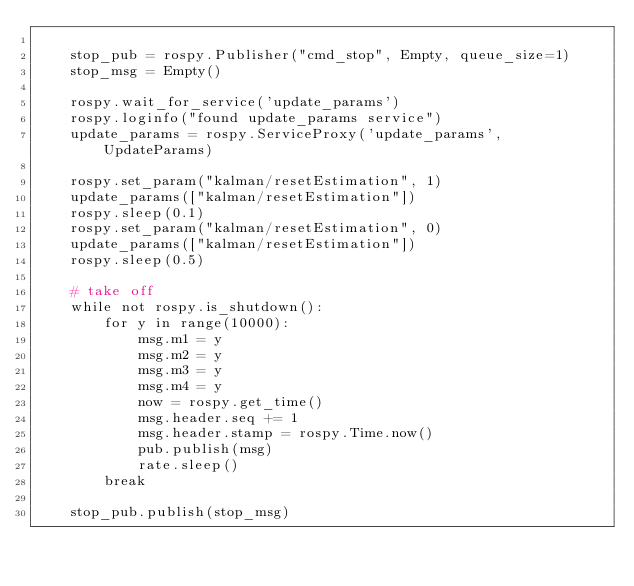<code> <loc_0><loc_0><loc_500><loc_500><_Python_>
    stop_pub = rospy.Publisher("cmd_stop", Empty, queue_size=1)
    stop_msg = Empty()

    rospy.wait_for_service('update_params')
    rospy.loginfo("found update_params service")
    update_params = rospy.ServiceProxy('update_params', UpdateParams)

    rospy.set_param("kalman/resetEstimation", 1)
    update_params(["kalman/resetEstimation"])
    rospy.sleep(0.1)
    rospy.set_param("kalman/resetEstimation", 0)
    update_params(["kalman/resetEstimation"])
    rospy.sleep(0.5)

    # take off
    while not rospy.is_shutdown():
        for y in range(10000):
            msg.m1 = y
            msg.m2 = y
            msg.m3 = y
            msg.m4 = y
            now = rospy.get_time()
            msg.header.seq += 1
            msg.header.stamp = rospy.Time.now()
            pub.publish(msg)
            rate.sleep()
        break

    stop_pub.publish(stop_msg)
</code> 